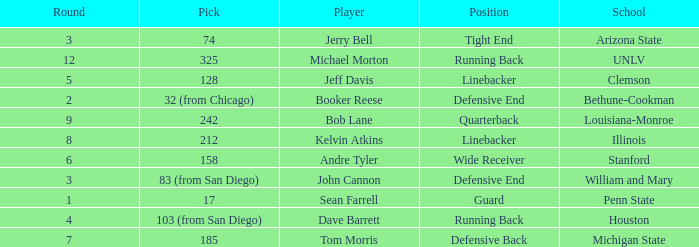Which round was Tom Morris picked in? 1.0. 